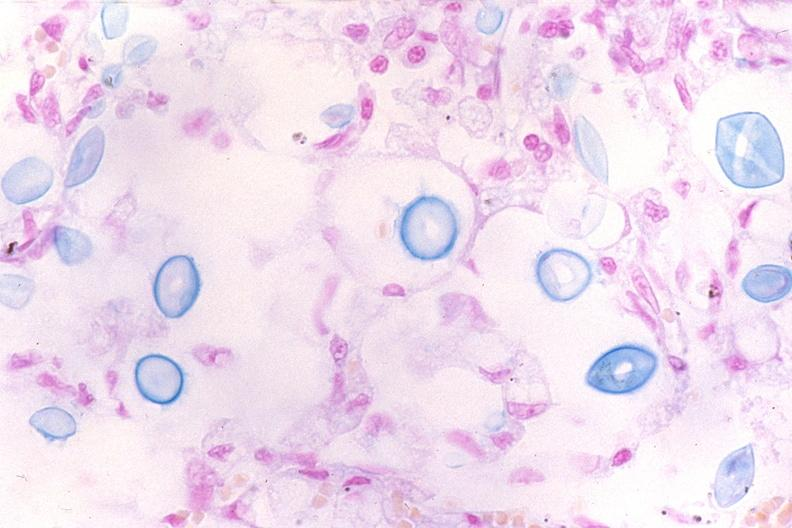do mucicarmine stain?
Answer the question using a single word or phrase. Yes 